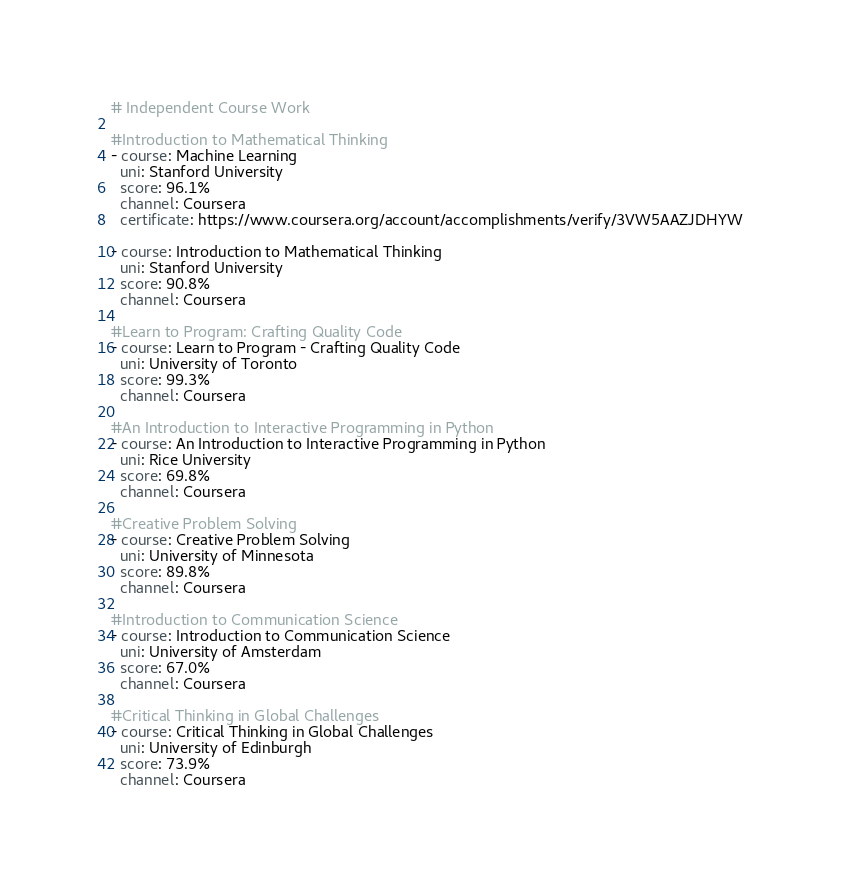Convert code to text. <code><loc_0><loc_0><loc_500><loc_500><_YAML_># Independent Course Work

#Introduction to Mathematical Thinking
- course: Machine Learning
  uni: Stanford University
  score: 96.1%
  channel: Coursera
  certificate: https://www.coursera.org/account/accomplishments/verify/3VW5AAZJDHYW  

- course: Introduction to Mathematical Thinking
  uni: Stanford University
  score: 90.8%
  channel: Coursera
  
#Learn to Program: Crafting Quality Code
- course: Learn to Program - Crafting Quality Code
  uni: University of Toronto  
  score: 99.3%
  channel: Coursera
  
#An Introduction to Interactive Programming in Python 
- course: An Introduction to Interactive Programming in Python 
  uni: Rice University
  score: 69.8%
  channel: Coursera
  
#Creative Problem Solving
- course: Creative Problem Solving
  uni: University of Minnesota
  score: 89.8%
  channel: Coursera
  
#Introduction to Communication Science
- course: Introduction to Communication Science
  uni: University of Amsterdam
  score: 67.0%
  channel: Coursera
  
#Critical Thinking in Global Challenges
- course: Critical Thinking in Global Challenges
  uni: University of Edinburgh
  score: 73.9%
  channel: Coursera</code> 